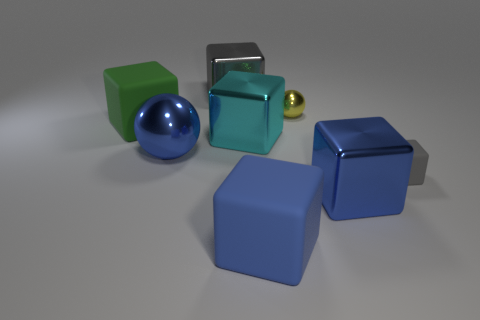Subtract all small matte blocks. How many blocks are left? 5 Subtract 2 spheres. How many spheres are left? 0 Subtract all gray cubes. How many cubes are left? 4 Subtract all balls. How many objects are left? 6 Add 2 large green cubes. How many objects exist? 10 Subtract 1 yellow balls. How many objects are left? 7 Subtract all purple blocks. Subtract all gray cylinders. How many blocks are left? 6 Subtract all purple cylinders. How many green blocks are left? 1 Subtract all red metal balls. Subtract all blue things. How many objects are left? 5 Add 5 yellow metallic balls. How many yellow metallic balls are left? 6 